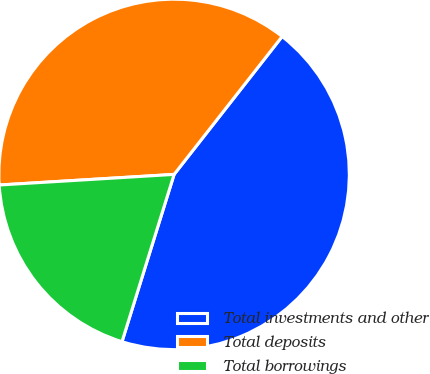<chart> <loc_0><loc_0><loc_500><loc_500><pie_chart><fcel>Total investments and other<fcel>Total deposits<fcel>Total borrowings<nl><fcel>44.23%<fcel>36.54%<fcel>19.23%<nl></chart> 